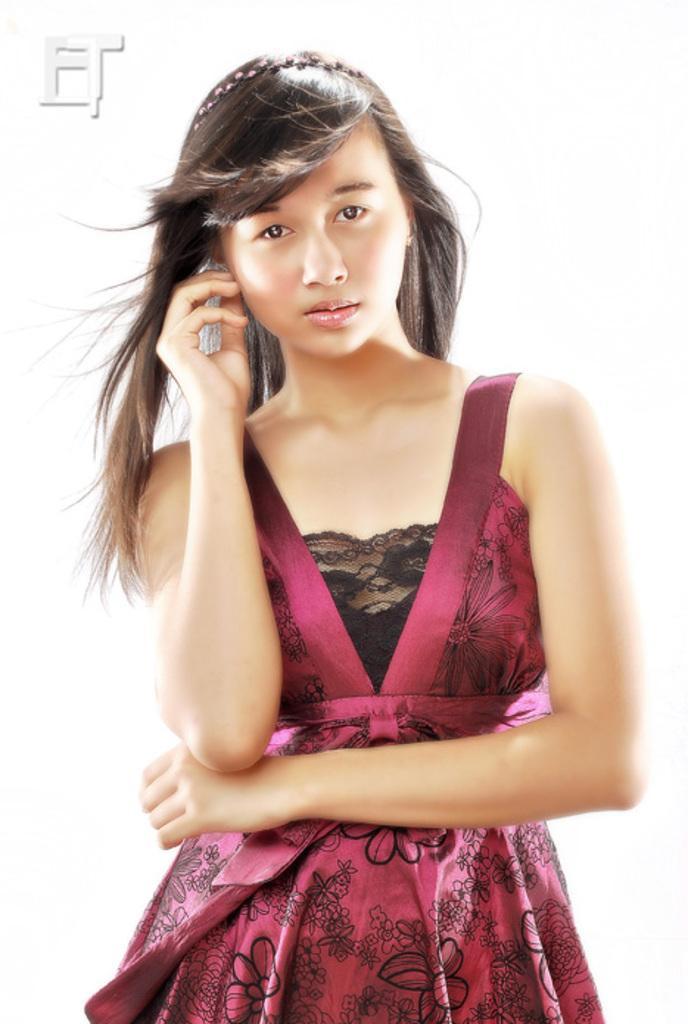Could you give a brief overview of what you see in this image? Background portion of the picture is white in color. In this picture we can see a woman wearing a dress. She is giving a pose and we can see a hair band on her head. 